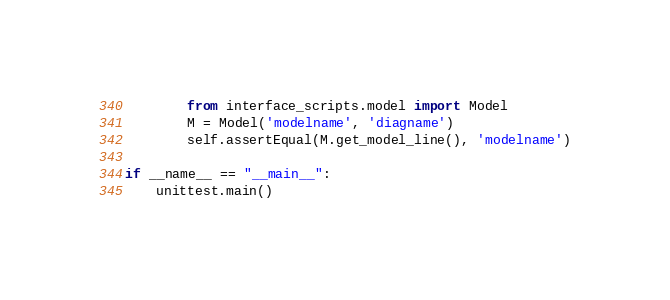<code> <loc_0><loc_0><loc_500><loc_500><_Python_>        from interface_scripts.model import Model
        M = Model('modelname', 'diagname')
        self.assertEqual(M.get_model_line(), 'modelname')

if __name__ == "__main__":
    unittest.main()


</code> 